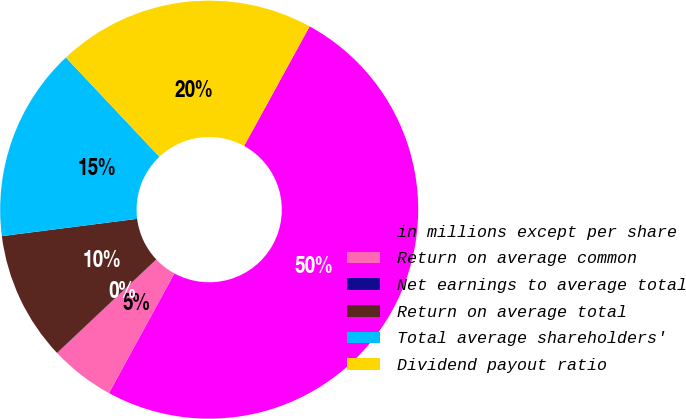Convert chart. <chart><loc_0><loc_0><loc_500><loc_500><pie_chart><fcel>in millions except per share<fcel>Return on average common<fcel>Net earnings to average total<fcel>Return on average total<fcel>Total average shareholders'<fcel>Dividend payout ratio<nl><fcel>49.98%<fcel>5.01%<fcel>0.01%<fcel>10.0%<fcel>15.0%<fcel>20.0%<nl></chart> 